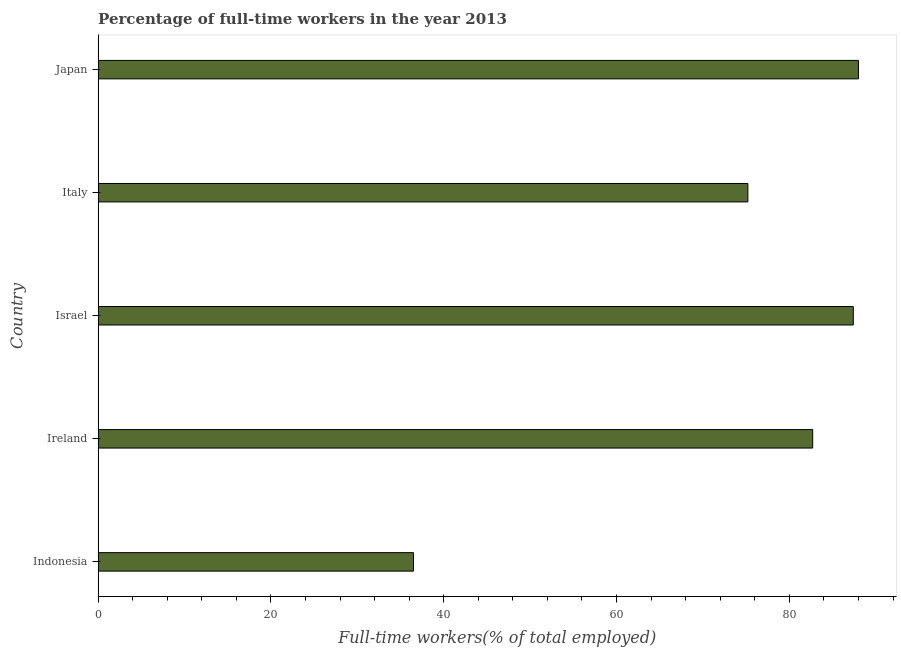What is the title of the graph?
Offer a very short reply. Percentage of full-time workers in the year 2013. What is the label or title of the X-axis?
Give a very brief answer. Full-time workers(% of total employed). What is the percentage of full-time workers in Ireland?
Your answer should be very brief. 82.7. Across all countries, what is the maximum percentage of full-time workers?
Offer a very short reply. 88. Across all countries, what is the minimum percentage of full-time workers?
Keep it short and to the point. 36.5. In which country was the percentage of full-time workers maximum?
Make the answer very short. Japan. What is the sum of the percentage of full-time workers?
Keep it short and to the point. 369.8. What is the difference between the percentage of full-time workers in Indonesia and Japan?
Ensure brevity in your answer.  -51.5. What is the average percentage of full-time workers per country?
Make the answer very short. 73.96. What is the median percentage of full-time workers?
Keep it short and to the point. 82.7. What is the ratio of the percentage of full-time workers in Indonesia to that in Ireland?
Your answer should be compact. 0.44. Is the percentage of full-time workers in Indonesia less than that in Italy?
Your answer should be compact. Yes. Is the difference between the percentage of full-time workers in Ireland and Israel greater than the difference between any two countries?
Provide a succinct answer. No. What is the difference between the highest and the second highest percentage of full-time workers?
Your answer should be very brief. 0.6. What is the difference between the highest and the lowest percentage of full-time workers?
Make the answer very short. 51.5. What is the difference between two consecutive major ticks on the X-axis?
Offer a terse response. 20. Are the values on the major ticks of X-axis written in scientific E-notation?
Your answer should be very brief. No. What is the Full-time workers(% of total employed) of Indonesia?
Your answer should be very brief. 36.5. What is the Full-time workers(% of total employed) of Ireland?
Keep it short and to the point. 82.7. What is the Full-time workers(% of total employed) of Israel?
Keep it short and to the point. 87.4. What is the Full-time workers(% of total employed) in Italy?
Provide a succinct answer. 75.2. What is the difference between the Full-time workers(% of total employed) in Indonesia and Ireland?
Offer a very short reply. -46.2. What is the difference between the Full-time workers(% of total employed) in Indonesia and Israel?
Give a very brief answer. -50.9. What is the difference between the Full-time workers(% of total employed) in Indonesia and Italy?
Your answer should be very brief. -38.7. What is the difference between the Full-time workers(% of total employed) in Indonesia and Japan?
Keep it short and to the point. -51.5. What is the difference between the Full-time workers(% of total employed) in Ireland and Israel?
Your answer should be very brief. -4.7. What is the difference between the Full-time workers(% of total employed) in Ireland and Italy?
Provide a short and direct response. 7.5. What is the difference between the Full-time workers(% of total employed) in Israel and Japan?
Keep it short and to the point. -0.6. What is the ratio of the Full-time workers(% of total employed) in Indonesia to that in Ireland?
Give a very brief answer. 0.44. What is the ratio of the Full-time workers(% of total employed) in Indonesia to that in Israel?
Ensure brevity in your answer.  0.42. What is the ratio of the Full-time workers(% of total employed) in Indonesia to that in Italy?
Make the answer very short. 0.48. What is the ratio of the Full-time workers(% of total employed) in Indonesia to that in Japan?
Make the answer very short. 0.41. What is the ratio of the Full-time workers(% of total employed) in Ireland to that in Israel?
Offer a very short reply. 0.95. What is the ratio of the Full-time workers(% of total employed) in Ireland to that in Italy?
Your answer should be compact. 1.1. What is the ratio of the Full-time workers(% of total employed) in Israel to that in Italy?
Offer a terse response. 1.16. What is the ratio of the Full-time workers(% of total employed) in Israel to that in Japan?
Provide a succinct answer. 0.99. What is the ratio of the Full-time workers(% of total employed) in Italy to that in Japan?
Your answer should be compact. 0.85. 